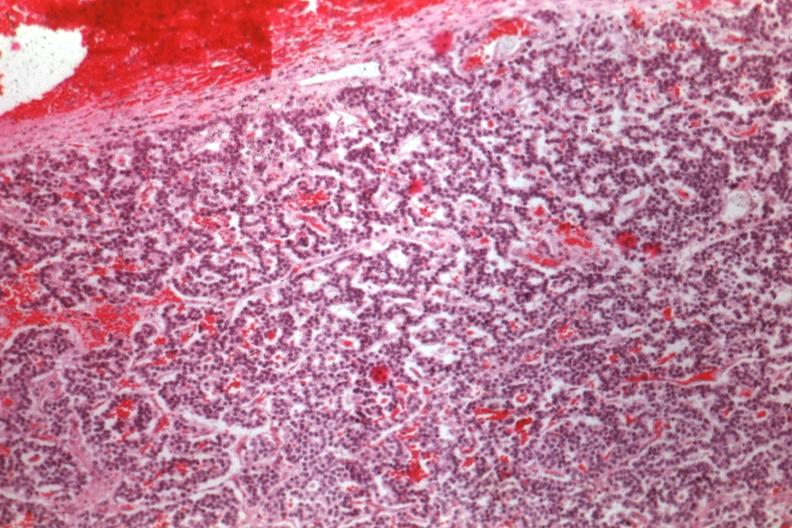where is this part in the figure?
Answer the question using a single word or phrase. Endocrine system 